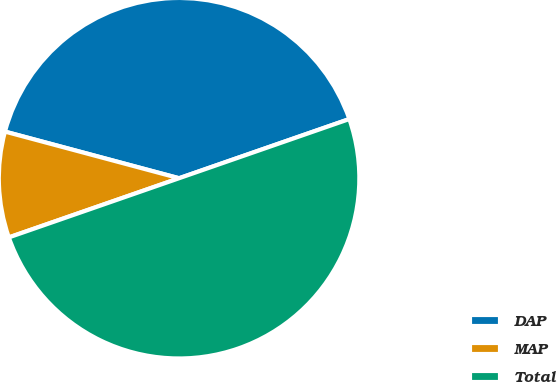<chart> <loc_0><loc_0><loc_500><loc_500><pie_chart><fcel>DAP<fcel>MAP<fcel>Total<nl><fcel>40.51%<fcel>9.49%<fcel>50.0%<nl></chart> 